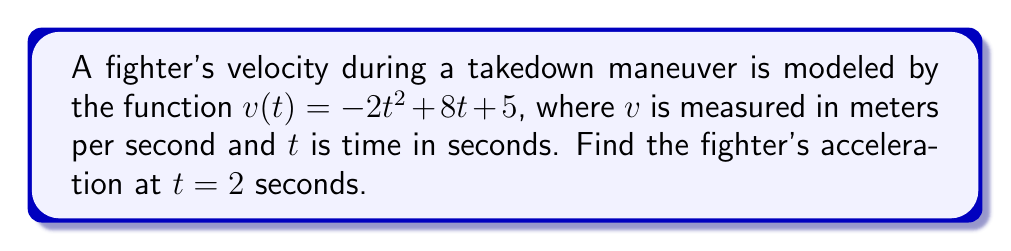Provide a solution to this math problem. To find the acceleration, we need to follow these steps:

1) Recall that acceleration is the derivative of velocity with respect to time.

2) Given: $v(t) = -2t^2 + 8t + 5$

3) To find acceleration, we need to differentiate $v(t)$:
   $$a(t) = \frac{d}{dt}v(t) = \frac{d}{dt}(-2t^2 + 8t + 5)$$

4) Using the power rule and constant rule of differentiation:
   $$a(t) = -2 \cdot 2t + 8 = -4t + 8$$

5) Now that we have the acceleration function, we can find the acceleration at $t = 2$ seconds:
   $$a(2) = -4(2) + 8 = -8 + 8 = 0$$

Therefore, the fighter's acceleration at $t = 2$ seconds is 0 m/s².
Answer: $0$ m/s² 